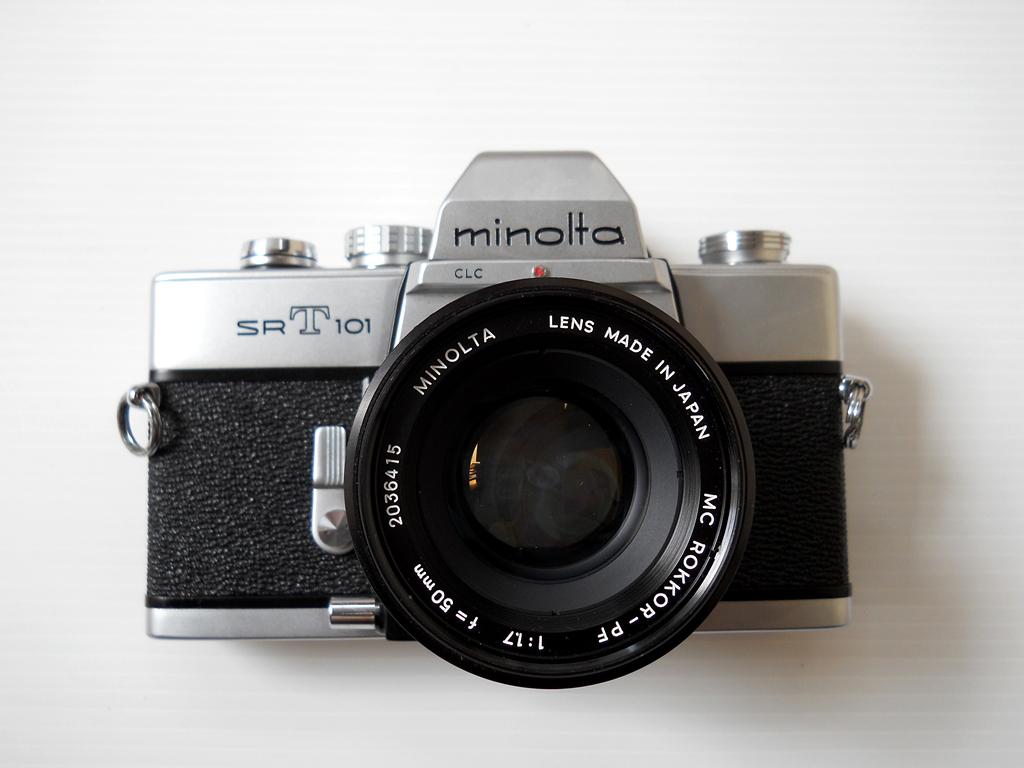What model is the minolta camera?
Give a very brief answer. Srt101. 